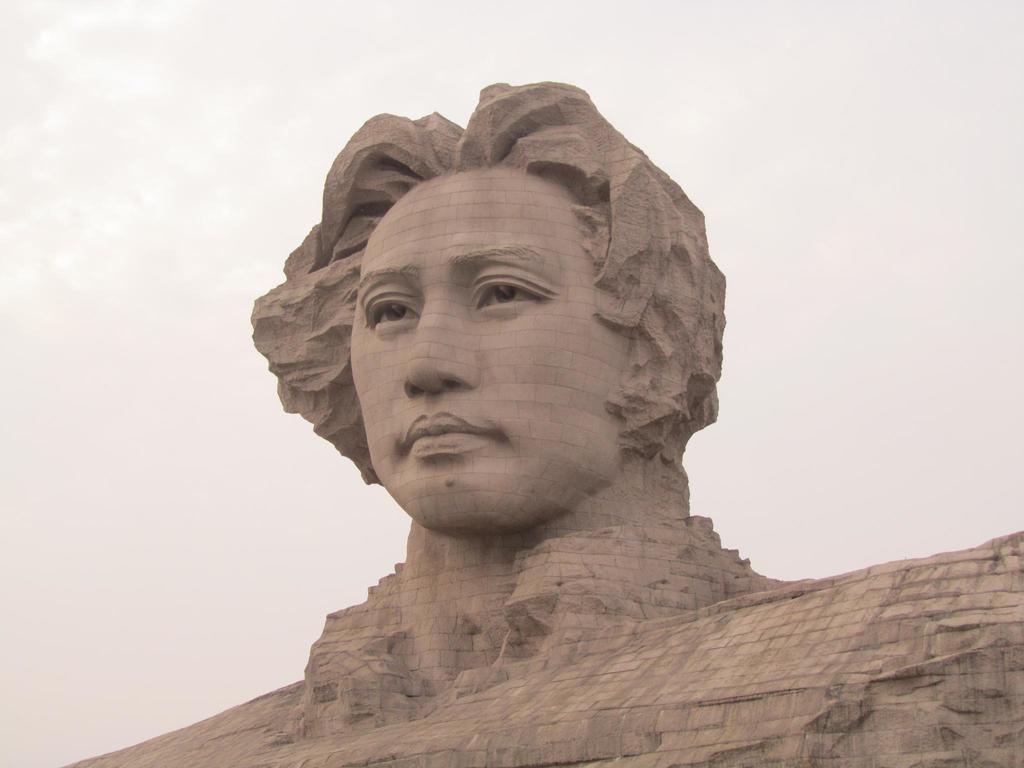How would you summarize this image in a sentence or two? In this picture we can see the statue of a person. Background we can see the sky. 